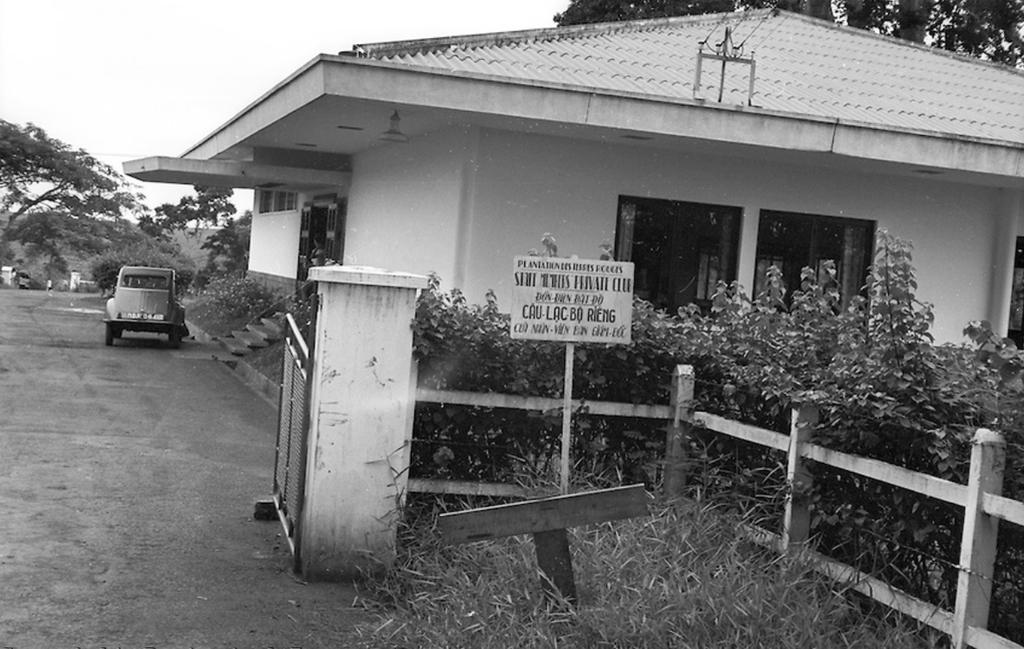What is the color scheme of the image? The image is black and white. What type of structures can be seen in the image? There are houses in the image. What other objects are near the houses? There are plants near the houses. What mode of transportation is visible in the image? There is a car on a road in the image. What can be seen in the background of the image? There are trees in the background of the image. Where is the airport located in the image? There is no airport present in the image. What type of doll can be seen playing with a dime in the image? There is no doll or dime present in the image. 